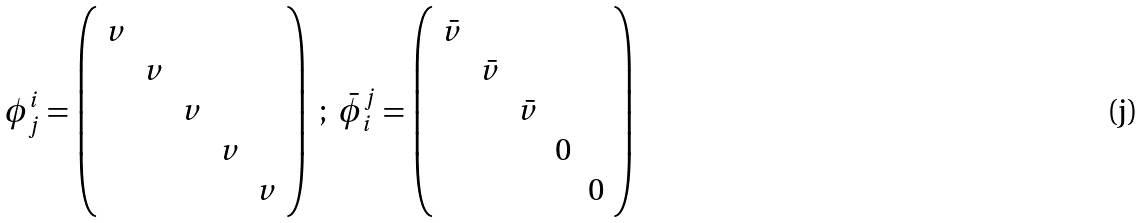Convert formula to latex. <formula><loc_0><loc_0><loc_500><loc_500>\phi ^ { i } _ { j } = \left ( \begin{array} { c c c c c } v & & & & \\ & v & & & \\ & & v & & \\ & & & v & \\ & & & & v \end{array} \right ) \ ; \ { \bar { \phi } } _ { i } ^ { j } = \left ( \begin{array} { c c c c c } { \bar { v } } & & & & \\ & { \bar { v } } & & & \\ & & { \bar { v } } & & \\ & & & 0 & \\ & & & & 0 \end{array} \right )</formula> 